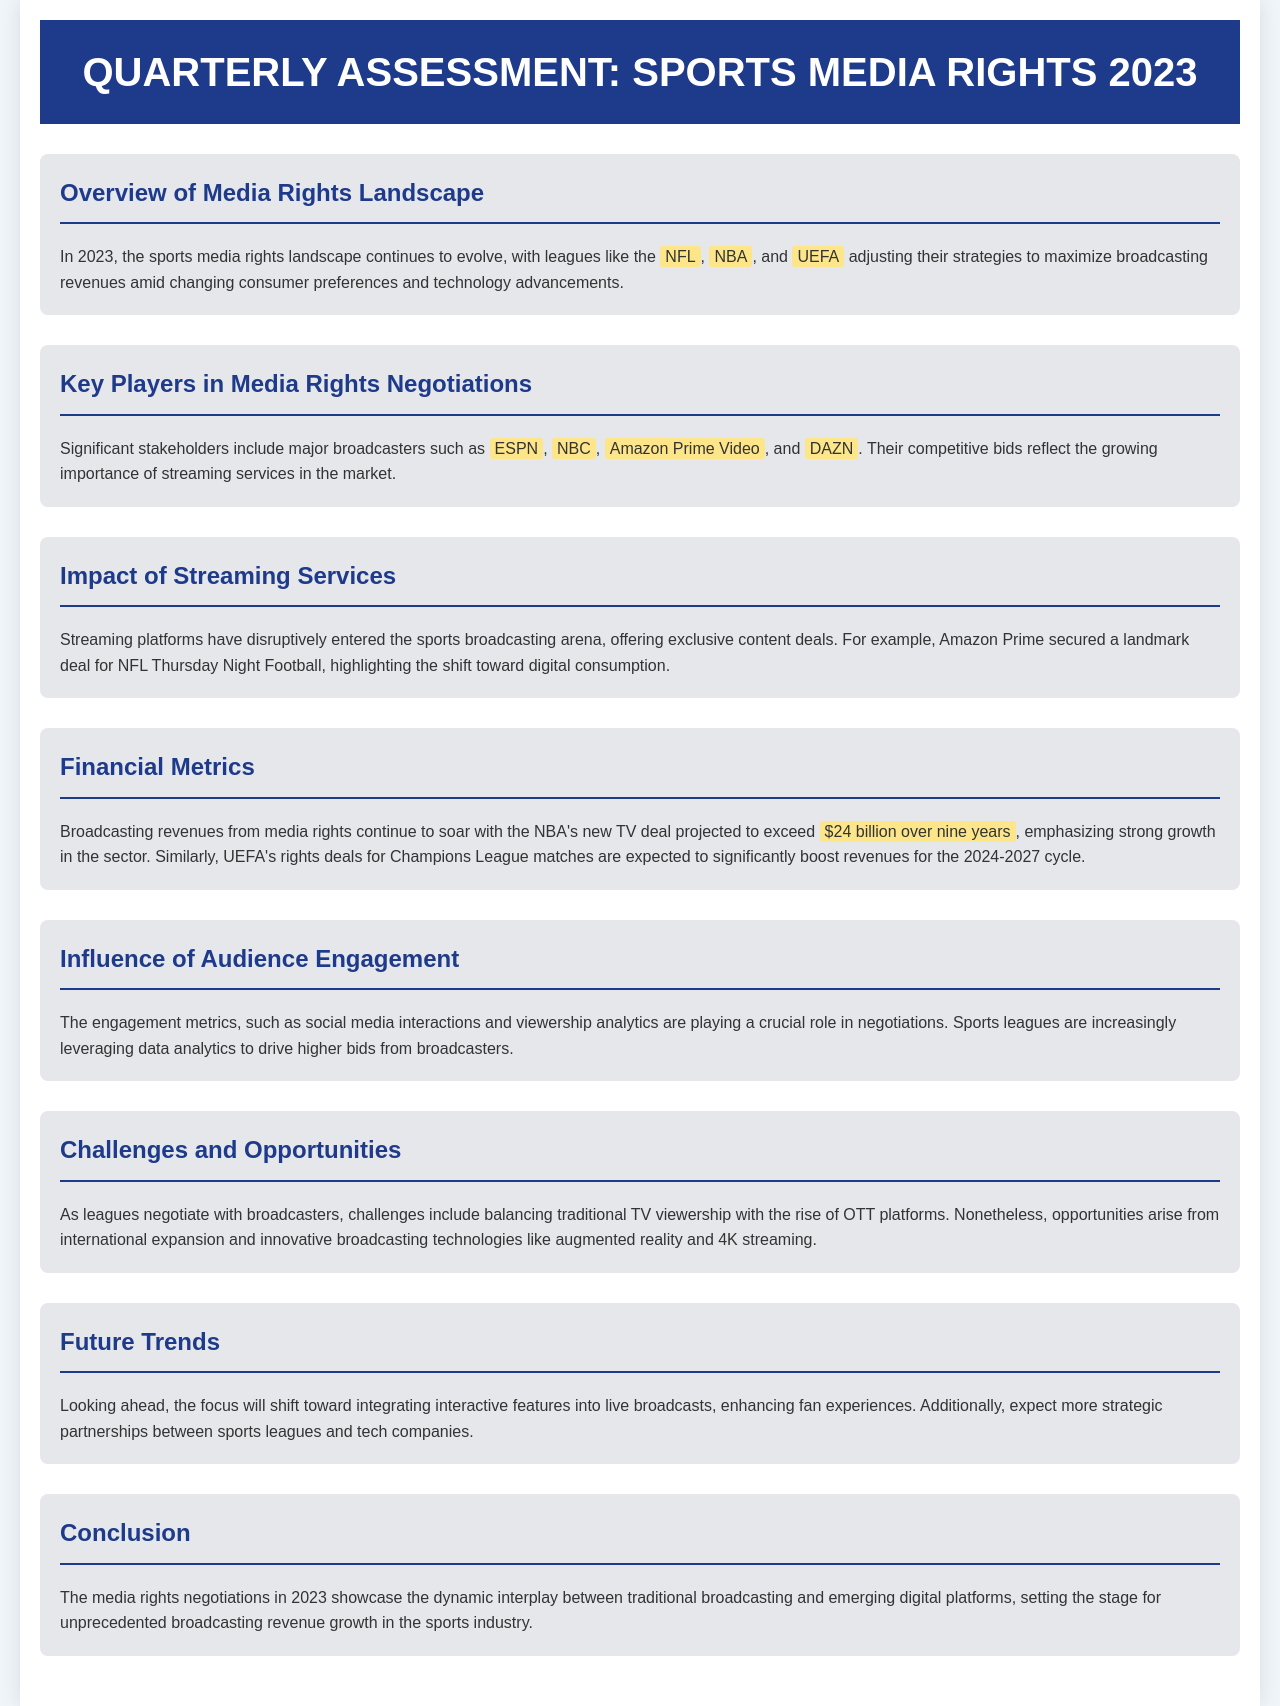What is the projected value of the NBA's new TV deal? The document indicates that the NBA's new TV deal is projected to exceed $24 billion over nine years.
Answer: $24 billion Which leagues are adjusting their strategies? The overview mentions leagues such as the NFL, NBA, and UEFA adjusting their strategies to maximize broadcasting revenues.
Answer: NFL, NBA, UEFA Who are the significant stakeholders in media rights negotiations? The document lists major broadcasters like ESPN, NBC, Amazon Prime Video, and DAZN as significant stakeholders.
Answer: ESPN, NBC, Amazon Prime Video, DAZN What has disrupted the sports broadcasting arena? The document states that streaming platforms have disruptively entered the sports broadcasting arena.
Answer: Streaming platforms What will be the focus of future trends in broadcasting? The future trends will focus on integrating interactive features into live broadcasts.
Answer: Integrating interactive features What is one challenge faced by leagues in negotiations? The document mentions the challenge of balancing traditional TV viewership with the rise of OTT platforms.
Answer: Balancing traditional TV viewership What type of content deal did Amazon Prime secure? Amazon Prime secured a landmark deal for NFL Thursday Night Football.
Answer: NFL Thursday Night Football What metrics are influencing media rights negotiations? Engagement metrics such as social media interactions and viewership analytics are influencing negotiations.
Answer: Social media interactions and viewership analytics 